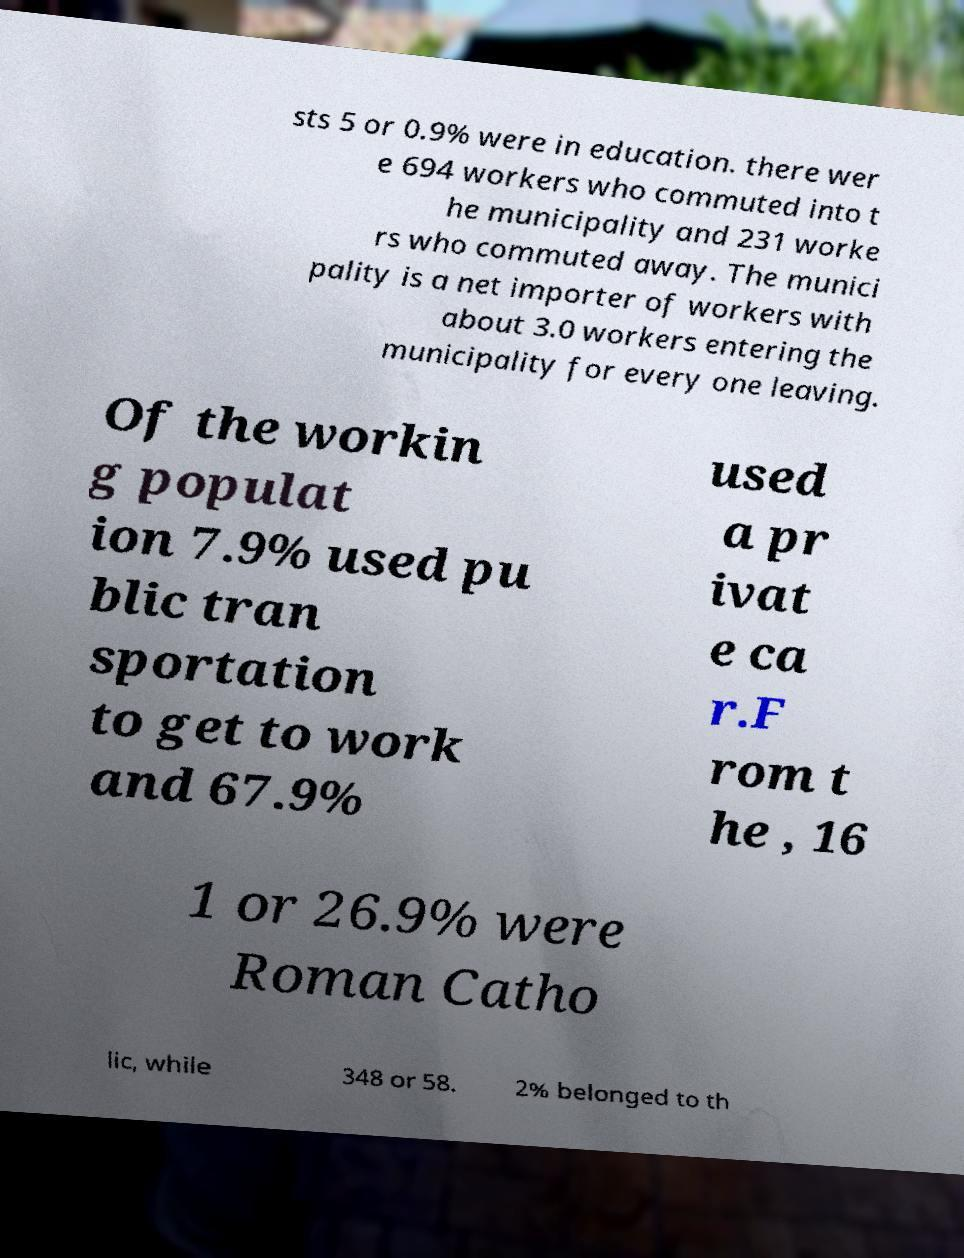Please read and relay the text visible in this image. What does it say? sts 5 or 0.9% were in education. there wer e 694 workers who commuted into t he municipality and 231 worke rs who commuted away. The munici pality is a net importer of workers with about 3.0 workers entering the municipality for every one leaving. Of the workin g populat ion 7.9% used pu blic tran sportation to get to work and 67.9% used a pr ivat e ca r.F rom t he , 16 1 or 26.9% were Roman Catho lic, while 348 or 58. 2% belonged to th 